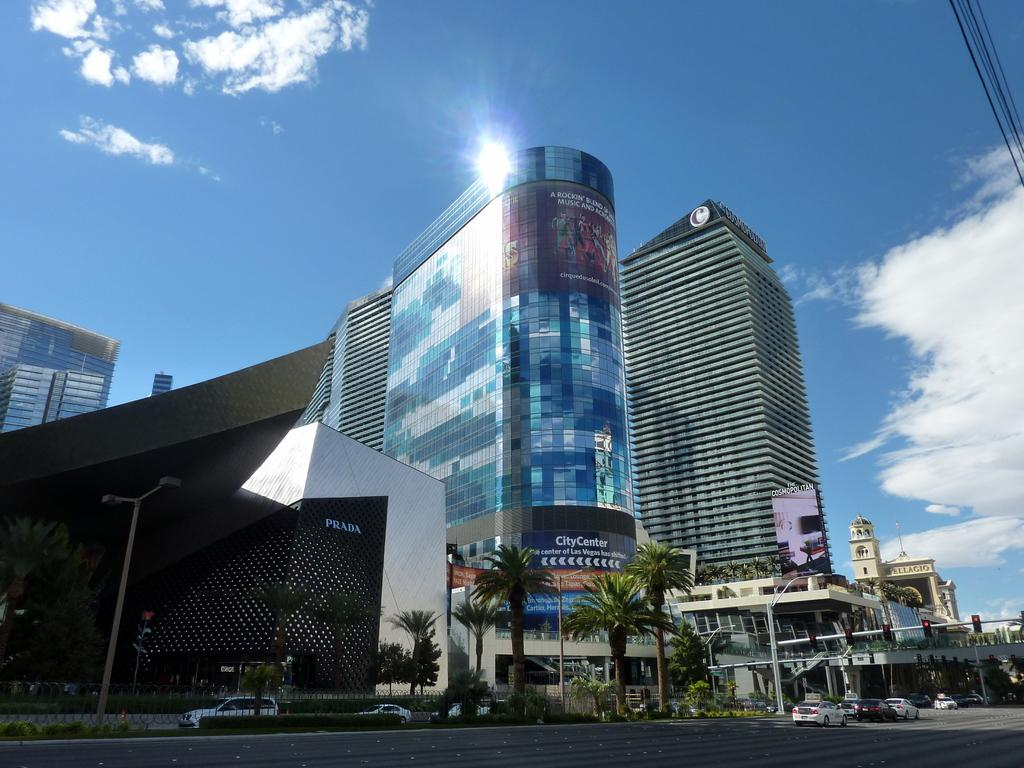<image>
Provide a brief description of the given image. A large mirrored building with a billboard remarking about how the center of Las Vegas has shifted. 